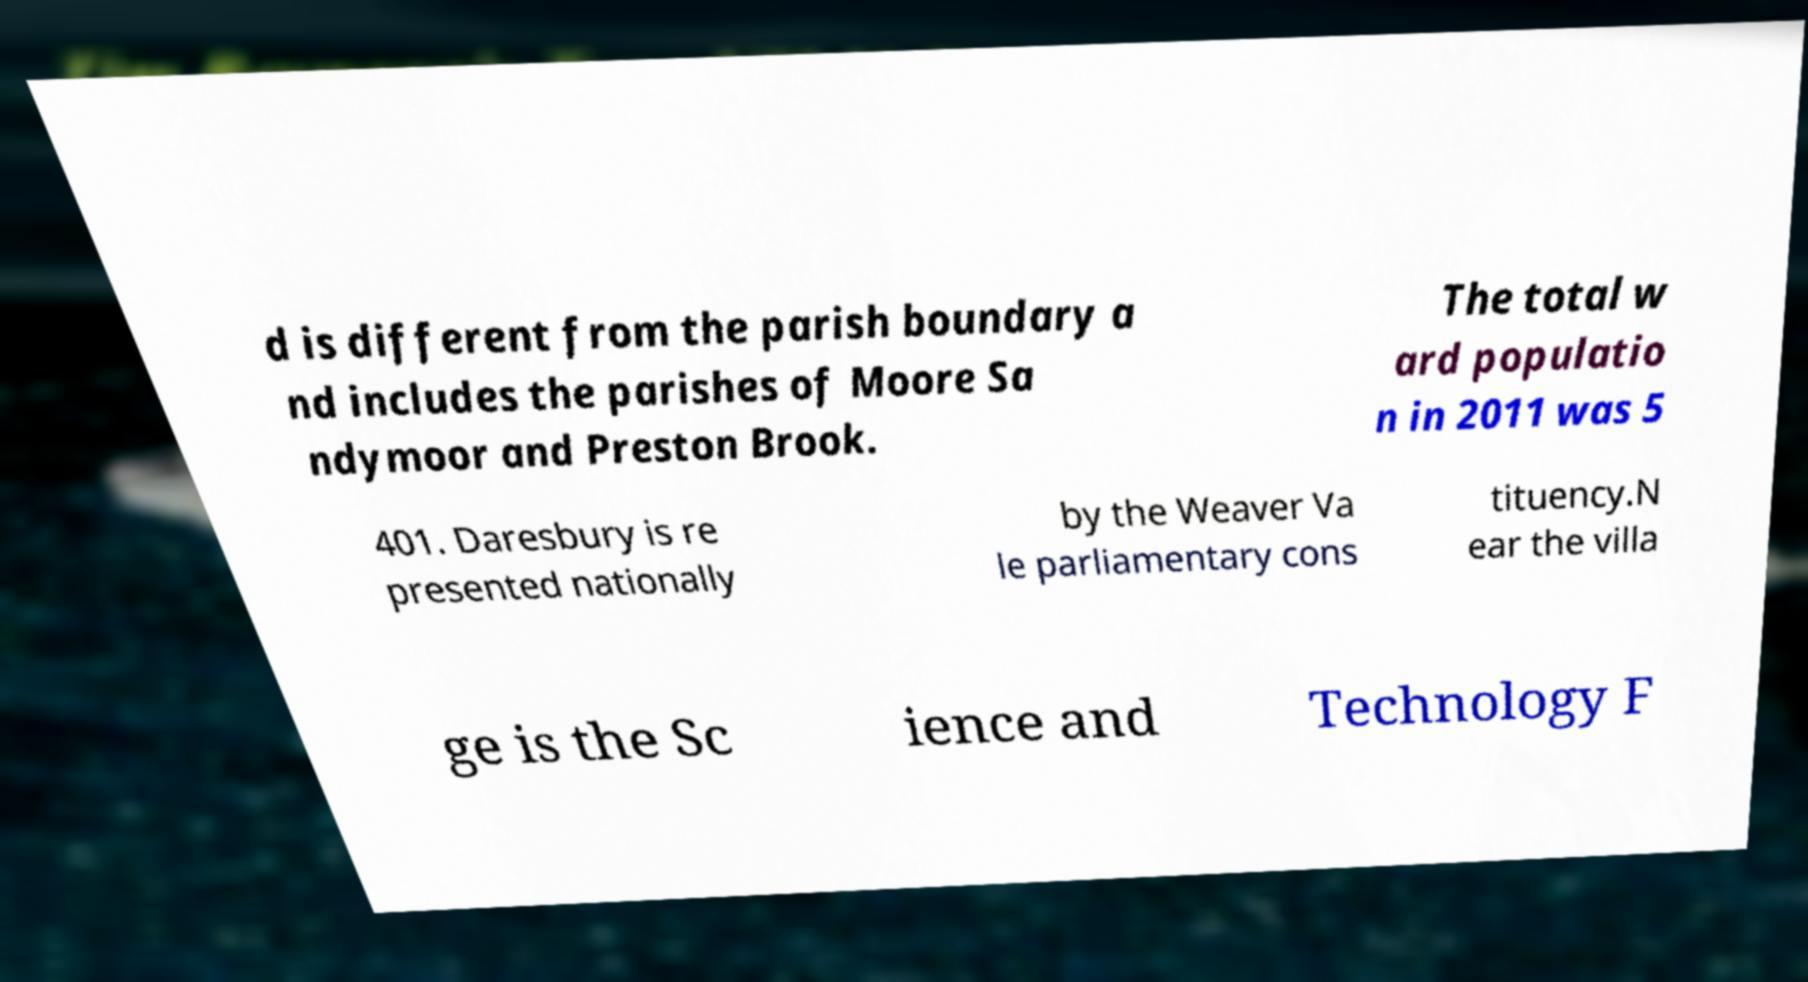Can you accurately transcribe the text from the provided image for me? d is different from the parish boundary a nd includes the parishes of Moore Sa ndymoor and Preston Brook. The total w ard populatio n in 2011 was 5 401. Daresbury is re presented nationally by the Weaver Va le parliamentary cons tituency.N ear the villa ge is the Sc ience and Technology F 